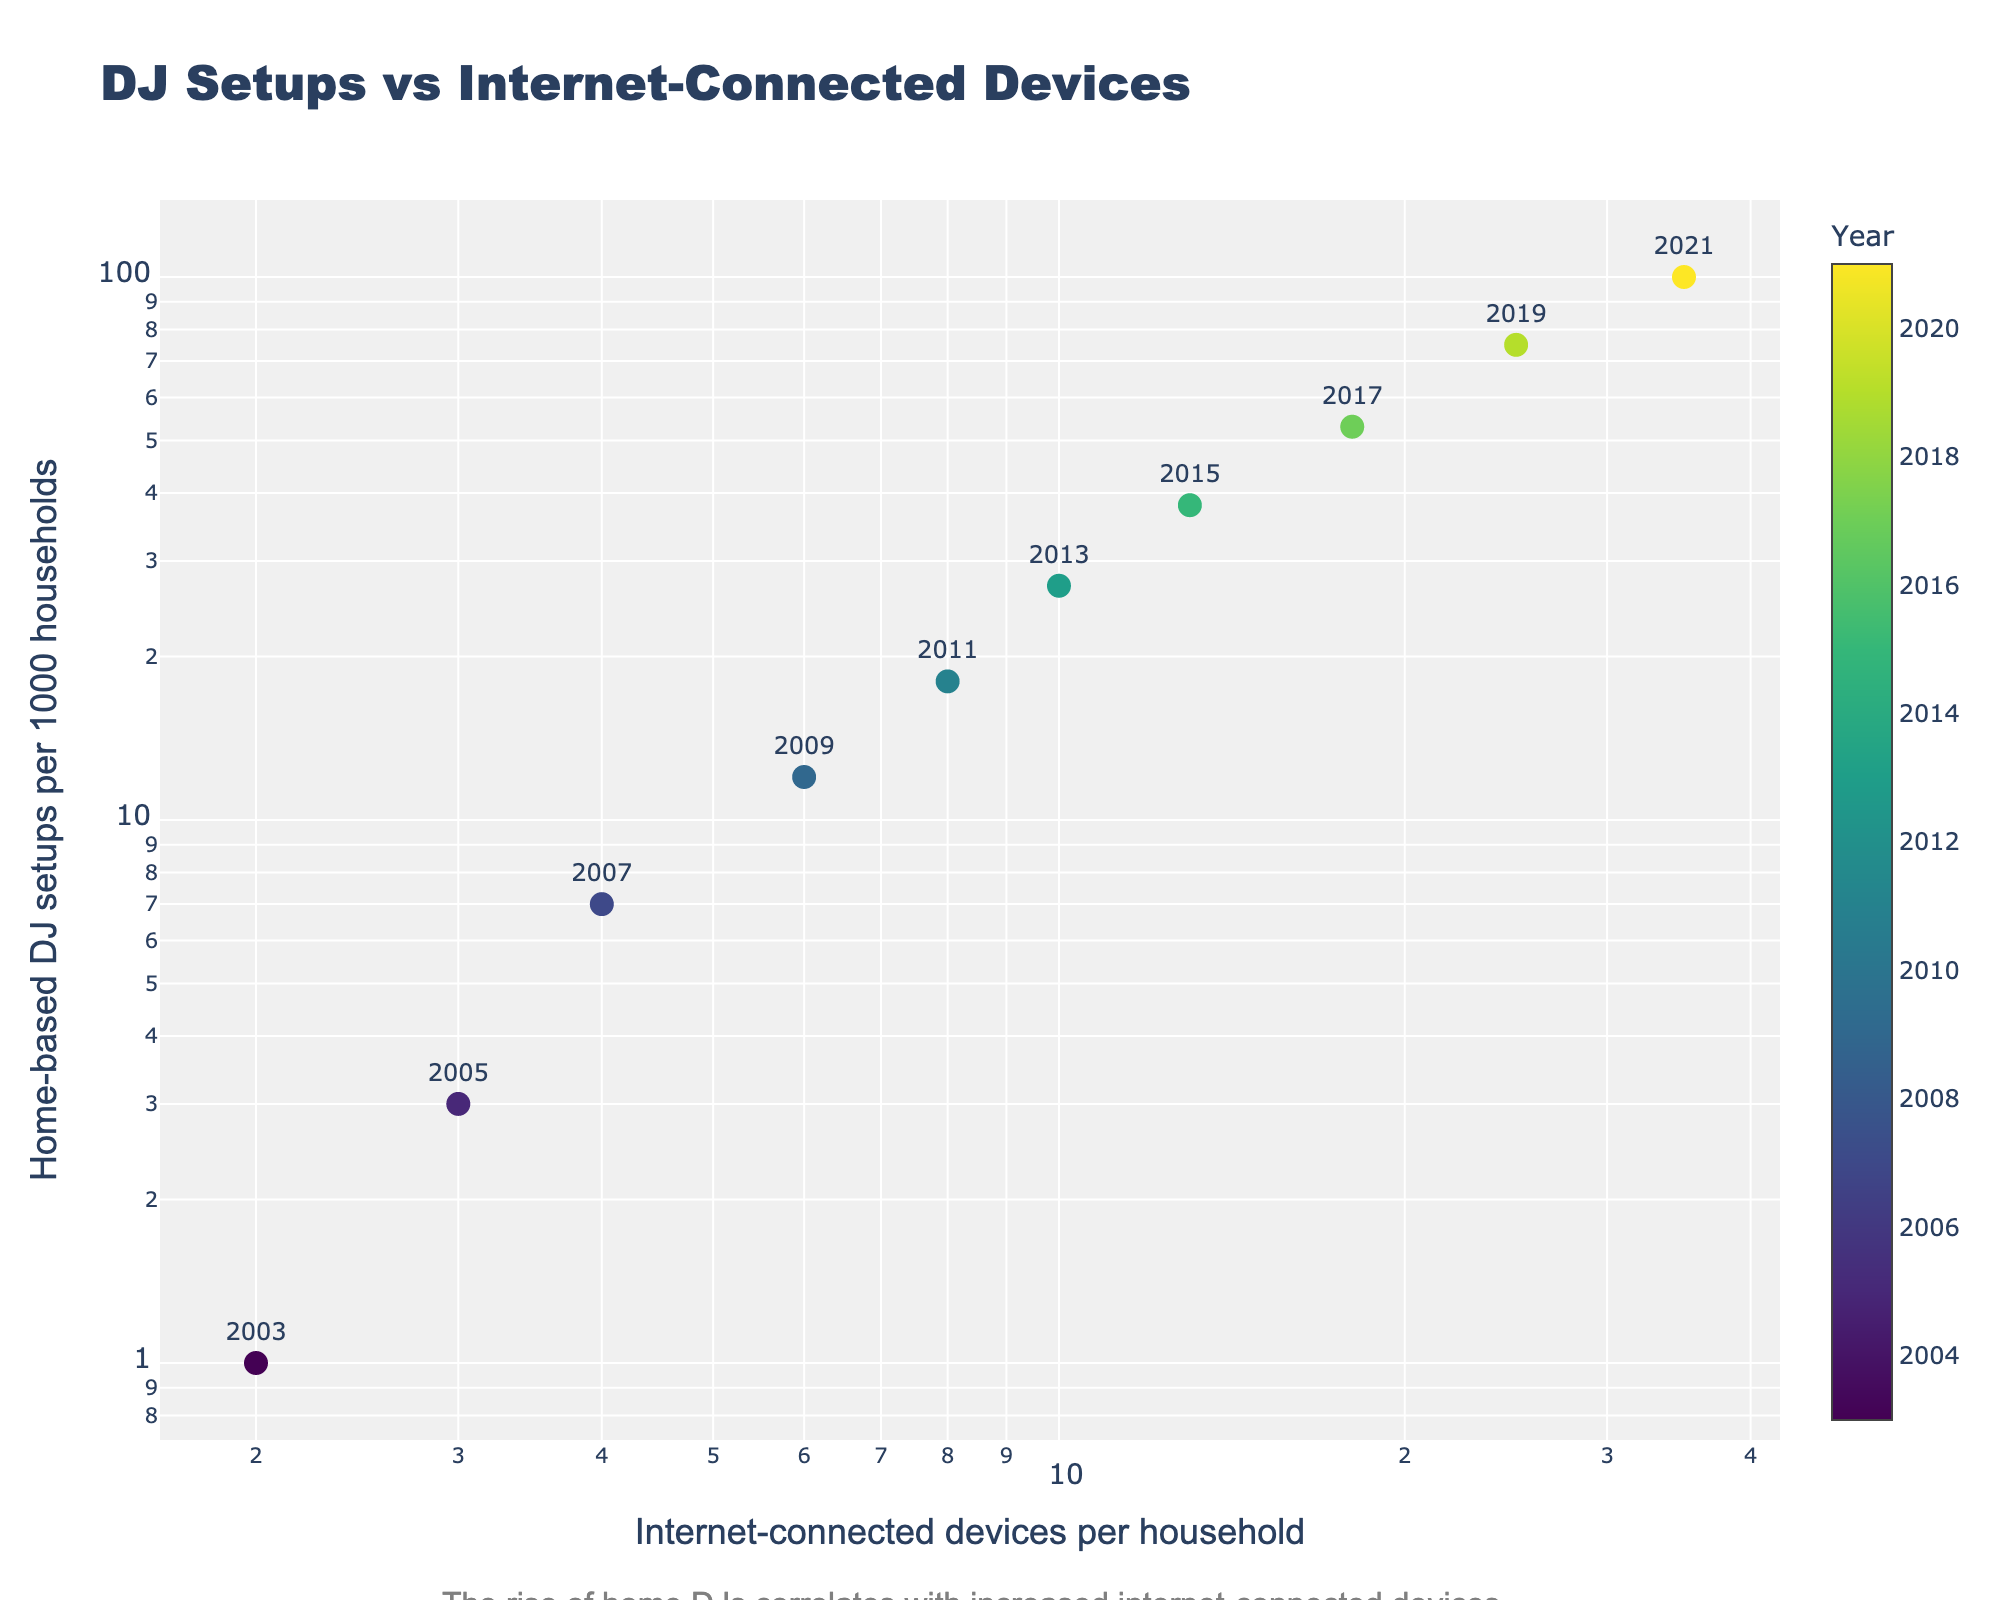What's the title of the figure? The title is at the top of the figure; it reads "DJ Setups vs Internet-Connected Devices".
Answer: DJ Setups vs Internet-Connected Devices What's the color scale on the markers used to represent? The color scale on the markers corresponds to the year, which is evident from the color bar titled "Year" on the right of the figure.
Answer: Year Which year has the highest number of internet-connected devices per household? According to the figure, the marker with the highest x-axis value (35) represents the year 2021.
Answer: 2021 How many internet-connected devices per household were there in 2011? From the figure, the marker labeled "2011" is positioned at an x-axis value of 8, indicating there were 8 devices per household.
Answer: 8 What is the trend between the number of home-based DJ setups and internet-connected devices per household over the years? The scatter plot shows a clear positive correlation where increased internet-connected devices correspond to an increase in DJ setups. The markers are roughly forming a rising trend line from lower left to upper right.
Answer: Positive correlation Between which two consecutive years is the largest increase in home-based DJ setups observed? Comparing the y-axis values, the largest increase in home-based DJ setups (difference in y-axis values) is between 2019 (75 setups) and 2021 (100 setups).
Answer: Between 2019 and 2021 What is the general shape or pattern of the data points? The data points create a pattern that indicates a strong positive correlation, increasing from lower left to upper right on the log-log scale.
Answer: Strong positive correlation Is the number of internet-connected devices per household increasing linearly or exponentially? The number of devices per household is increasing exponentially, as indicated by the log scale of the x-axis, where the values rise significantly faster over time.
Answer: Exponentially What is the proportional change in DJ setups per 1000 households from 2007 to 2009? In 2007, the y-value was 7, and in 2009 it was 12. The change is (12 - 7) / 7 = 5/7 ≈ 0.714, which is about a 71.4% increase.
Answer: Approximately 71.4% Within the plot, identify the range of years during which the number of DJ setups per 1000 households doubles. Focusing on doubling the y-values, 18 setups in 2011 to 38 setups in 2015 represents a doubling in DJ setups. The range is from 2011 to 2015.
Answer: 2011 to 2015 